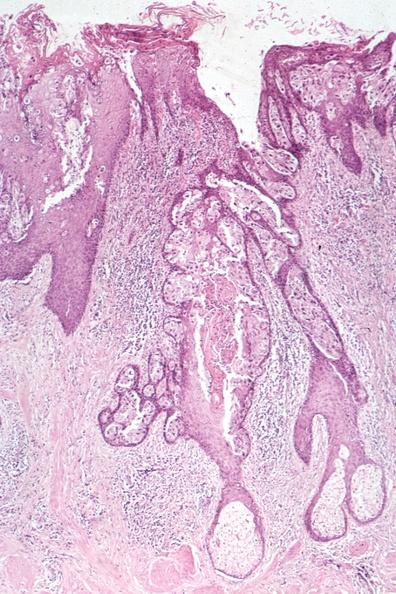what is this image of pagets disease?
Answer the question using a single word or phrase. A quite good example 